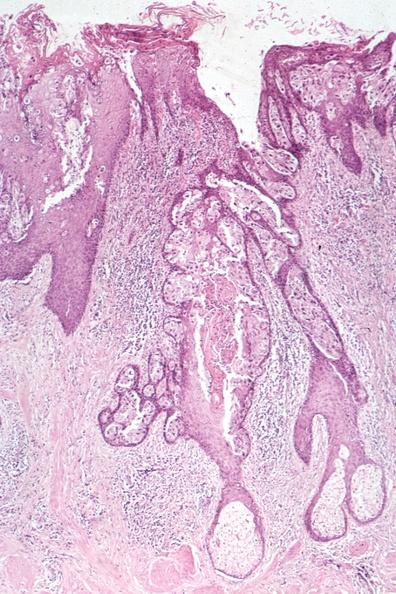what is this image of pagets disease?
Answer the question using a single word or phrase. A quite good example 